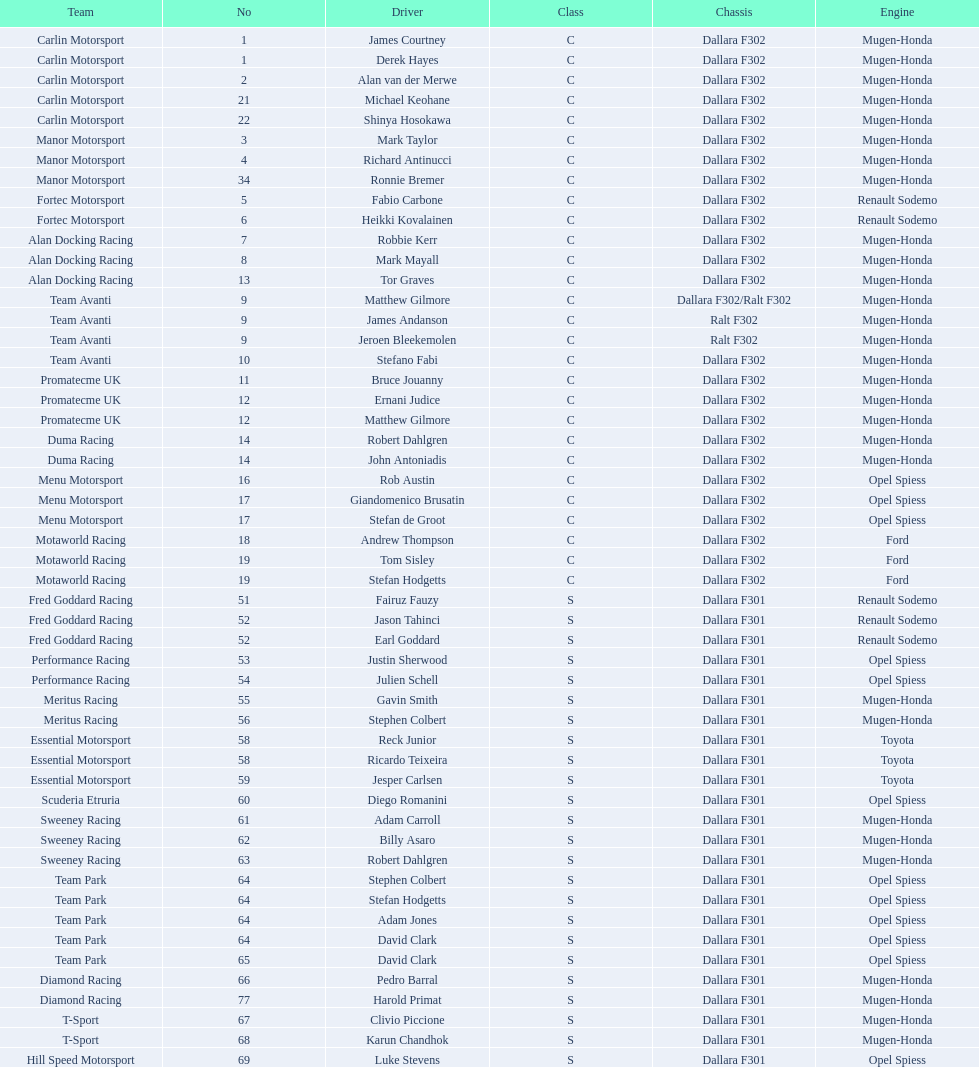Can you give me this table as a dict? {'header': ['Team', 'No', 'Driver', 'Class', 'Chassis', 'Engine'], 'rows': [['Carlin Motorsport', '1', 'James Courtney', 'C', 'Dallara F302', 'Mugen-Honda'], ['Carlin Motorsport', '1', 'Derek Hayes', 'C', 'Dallara F302', 'Mugen-Honda'], ['Carlin Motorsport', '2', 'Alan van der Merwe', 'C', 'Dallara F302', 'Mugen-Honda'], ['Carlin Motorsport', '21', 'Michael Keohane', 'C', 'Dallara F302', 'Mugen-Honda'], ['Carlin Motorsport', '22', 'Shinya Hosokawa', 'C', 'Dallara F302', 'Mugen-Honda'], ['Manor Motorsport', '3', 'Mark Taylor', 'C', 'Dallara F302', 'Mugen-Honda'], ['Manor Motorsport', '4', 'Richard Antinucci', 'C', 'Dallara F302', 'Mugen-Honda'], ['Manor Motorsport', '34', 'Ronnie Bremer', 'C', 'Dallara F302', 'Mugen-Honda'], ['Fortec Motorsport', '5', 'Fabio Carbone', 'C', 'Dallara F302', 'Renault Sodemo'], ['Fortec Motorsport', '6', 'Heikki Kovalainen', 'C', 'Dallara F302', 'Renault Sodemo'], ['Alan Docking Racing', '7', 'Robbie Kerr', 'C', 'Dallara F302', 'Mugen-Honda'], ['Alan Docking Racing', '8', 'Mark Mayall', 'C', 'Dallara F302', 'Mugen-Honda'], ['Alan Docking Racing', '13', 'Tor Graves', 'C', 'Dallara F302', 'Mugen-Honda'], ['Team Avanti', '9', 'Matthew Gilmore', 'C', 'Dallara F302/Ralt F302', 'Mugen-Honda'], ['Team Avanti', '9', 'James Andanson', 'C', 'Ralt F302', 'Mugen-Honda'], ['Team Avanti', '9', 'Jeroen Bleekemolen', 'C', 'Ralt F302', 'Mugen-Honda'], ['Team Avanti', '10', 'Stefano Fabi', 'C', 'Dallara F302', 'Mugen-Honda'], ['Promatecme UK', '11', 'Bruce Jouanny', 'C', 'Dallara F302', 'Mugen-Honda'], ['Promatecme UK', '12', 'Ernani Judice', 'C', 'Dallara F302', 'Mugen-Honda'], ['Promatecme UK', '12', 'Matthew Gilmore', 'C', 'Dallara F302', 'Mugen-Honda'], ['Duma Racing', '14', 'Robert Dahlgren', 'C', 'Dallara F302', 'Mugen-Honda'], ['Duma Racing', '14', 'John Antoniadis', 'C', 'Dallara F302', 'Mugen-Honda'], ['Menu Motorsport', '16', 'Rob Austin', 'C', 'Dallara F302', 'Opel Spiess'], ['Menu Motorsport', '17', 'Giandomenico Brusatin', 'C', 'Dallara F302', 'Opel Spiess'], ['Menu Motorsport', '17', 'Stefan de Groot', 'C', 'Dallara F302', 'Opel Spiess'], ['Motaworld Racing', '18', 'Andrew Thompson', 'C', 'Dallara F302', 'Ford'], ['Motaworld Racing', '19', 'Tom Sisley', 'C', 'Dallara F302', 'Ford'], ['Motaworld Racing', '19', 'Stefan Hodgetts', 'C', 'Dallara F302', 'Ford'], ['Fred Goddard Racing', '51', 'Fairuz Fauzy', 'S', 'Dallara F301', 'Renault Sodemo'], ['Fred Goddard Racing', '52', 'Jason Tahinci', 'S', 'Dallara F301', 'Renault Sodemo'], ['Fred Goddard Racing', '52', 'Earl Goddard', 'S', 'Dallara F301', 'Renault Sodemo'], ['Performance Racing', '53', 'Justin Sherwood', 'S', 'Dallara F301', 'Opel Spiess'], ['Performance Racing', '54', 'Julien Schell', 'S', 'Dallara F301', 'Opel Spiess'], ['Meritus Racing', '55', 'Gavin Smith', 'S', 'Dallara F301', 'Mugen-Honda'], ['Meritus Racing', '56', 'Stephen Colbert', 'S', 'Dallara F301', 'Mugen-Honda'], ['Essential Motorsport', '58', 'Reck Junior', 'S', 'Dallara F301', 'Toyota'], ['Essential Motorsport', '58', 'Ricardo Teixeira', 'S', 'Dallara F301', 'Toyota'], ['Essential Motorsport', '59', 'Jesper Carlsen', 'S', 'Dallara F301', 'Toyota'], ['Scuderia Etruria', '60', 'Diego Romanini', 'S', 'Dallara F301', 'Opel Spiess'], ['Sweeney Racing', '61', 'Adam Carroll', 'S', 'Dallara F301', 'Mugen-Honda'], ['Sweeney Racing', '62', 'Billy Asaro', 'S', 'Dallara F301', 'Mugen-Honda'], ['Sweeney Racing', '63', 'Robert Dahlgren', 'S', 'Dallara F301', 'Mugen-Honda'], ['Team Park', '64', 'Stephen Colbert', 'S', 'Dallara F301', 'Opel Spiess'], ['Team Park', '64', 'Stefan Hodgetts', 'S', 'Dallara F301', 'Opel Spiess'], ['Team Park', '64', 'Adam Jones', 'S', 'Dallara F301', 'Opel Spiess'], ['Team Park', '64', 'David Clark', 'S', 'Dallara F301', 'Opel Spiess'], ['Team Park', '65', 'David Clark', 'S', 'Dallara F301', 'Opel Spiess'], ['Diamond Racing', '66', 'Pedro Barral', 'S', 'Dallara F301', 'Mugen-Honda'], ['Diamond Racing', '77', 'Harold Primat', 'S', 'Dallara F301', 'Mugen-Honda'], ['T-Sport', '67', 'Clivio Piccione', 'S', 'Dallara F301', 'Mugen-Honda'], ['T-Sport', '68', 'Karun Chandhok', 'S', 'Dallara F301', 'Mugen-Honda'], ['Hill Speed Motorsport', '69', 'Luke Stevens', 'S', 'Dallara F301', 'Opel Spiess']]} What is the average number of teams that had a mugen-honda engine? 24. 